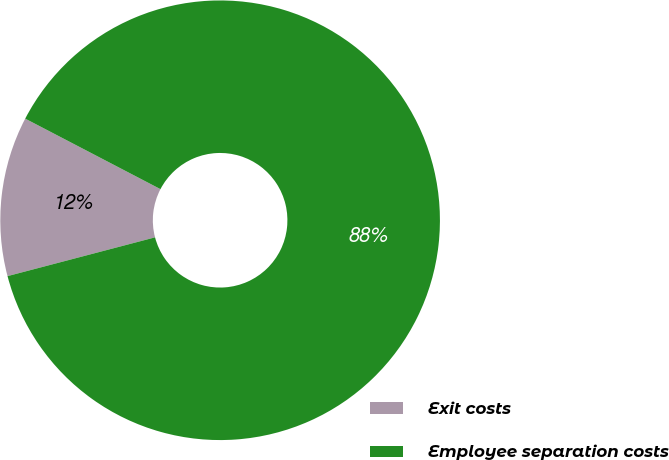Convert chart. <chart><loc_0><loc_0><loc_500><loc_500><pie_chart><fcel>Exit costs<fcel>Employee separation costs<nl><fcel>11.74%<fcel>88.26%<nl></chart> 